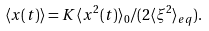<formula> <loc_0><loc_0><loc_500><loc_500>\langle x ( t ) \rangle = K \langle x ^ { 2 } ( t ) \rangle _ { 0 } / ( 2 \langle \xi ^ { 2 } \rangle _ { e q } ) .</formula> 